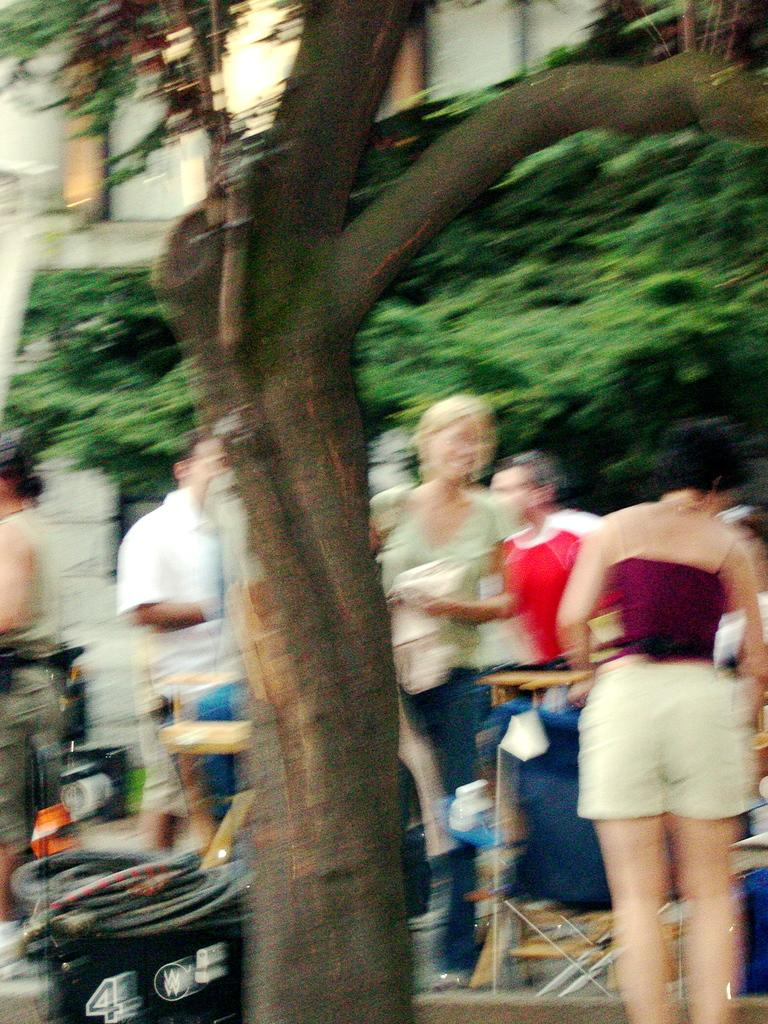What is the main subject in the center of the image? There is a tree in the center of the image. What can be seen in the background of the image? There are persons and at least one tree in the background of the image. What type of structure is visible in the background of the image? There is a building in the background of the image. How many toy cows are grazing near the tree in the image? There are no toy cows present in the image. What type of wind can be seen blowing through the image? There is no wind visible in the image, and therefore no specific type of wind can be identified. 